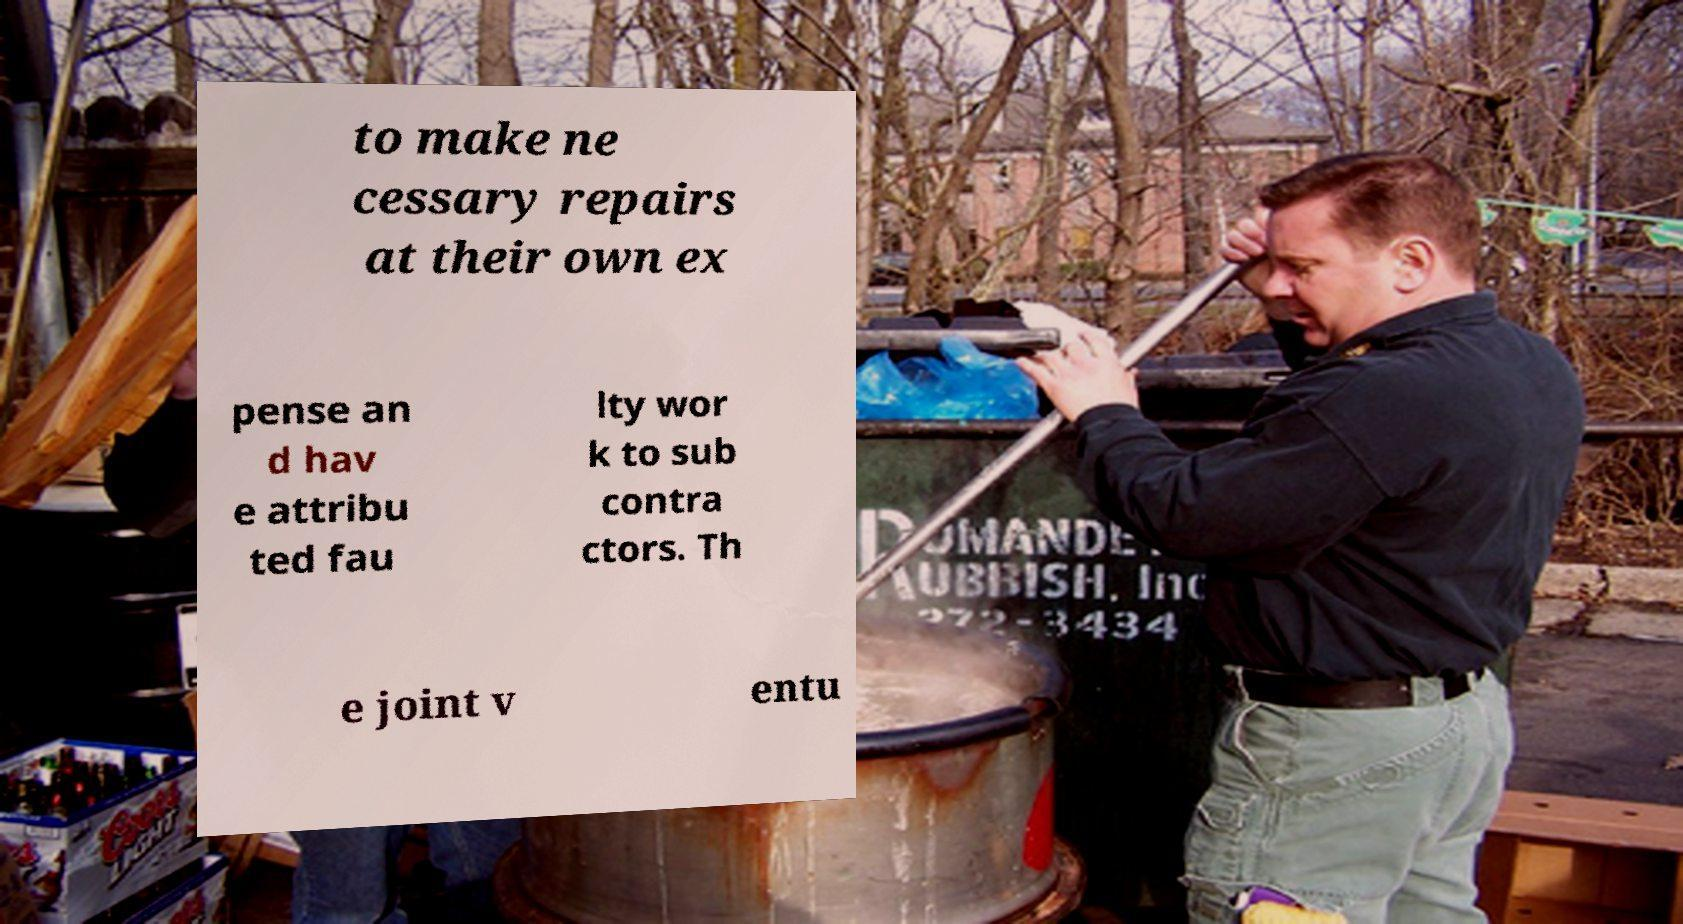Could you assist in decoding the text presented in this image and type it out clearly? to make ne cessary repairs at their own ex pense an d hav e attribu ted fau lty wor k to sub contra ctors. Th e joint v entu 